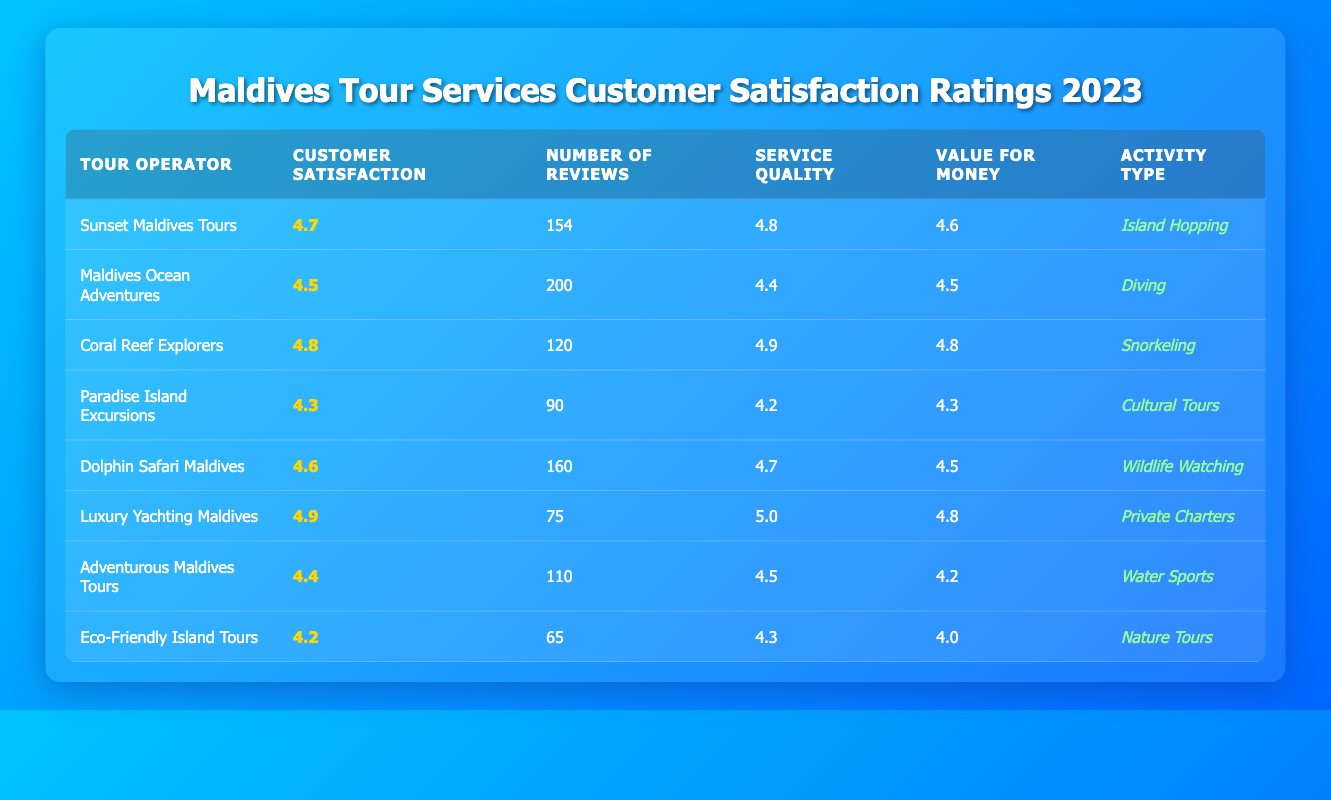What is the highest customer satisfaction rating among the tour operators? By reviewing the customer satisfaction ratings listed in the table, the values are 4.7, 4.5, 4.8, 4.3, 4.6, 4.9, 4.4, and 4.2. The highest value among these is 4.9.
Answer: 4.9 Which tour operator has the most reviews? The table includes the number of reviews for each operator: 154, 200, 120, 90, 160, 75, 110, and 65. The largest number, 200, is associated with Maldives Ocean Adventures.
Answer: Maldives Ocean Adventures Is there a tour operator with a customer satisfaction rating above 4.5 that also offers Wildlife Watching? Dolphin Safari Maldives has a customer satisfaction rating of 4.6, which is above 4.5, and offers Wildlife Watching, as indicated in the Activity Type column.
Answer: Yes What is the average service quality rating for all the tour operators? The service quality ratings are 4.8, 4.4, 4.9, 4.2, 4.7, 5.0, 4.5, and 4.3. Adding these values gives 36.8, and there are 8 operators, so the average is 36.8 / 8 = 4.6.
Answer: 4.6 Which activity type has the lowest customer satisfaction rating? Looking at the customer satisfaction ratings, the values are 4.7, 4.5, 4.8, 4.3, 4.6, 4.9, 4.4, and 4.2. The lowest value is 4.2, corresponding to Eco-Friendly Island Tours, which is categorized under Nature Tours.
Answer: Nature Tours How many tour operators have a value for money rating of 4.5 or higher? The value for money ratings are 4.6, 4.5, 4.8, 4.3, 4.5, 4.8, 4.2, and 4.0. Counting those rated 4.5 or higher gives us 5 operators (Sunset Maldives Tours, Maldives Ocean Adventures, Coral Reef Explorers, Dolphin Safari Maldives, and Luxury Yachting Maldives).
Answer: 5 Which tour operator provides the best service quality? By comparing the service quality ratings: 4.8, 4.4, 4.9, 4.2, 4.7, 5.0, 4.5, and 4.3, the highest rating is 5.0, which belongs to Luxury Yachting Maldives.
Answer: Luxury Yachting Maldives What is the difference in customer satisfaction ratings between the highest and lowest rated operators? The highest rating is 4.9 (Luxury Yachting Maldives) and the lowest is 4.2 (Eco-Friendly Island Tours). The difference is 4.9 - 4.2 = 0.7.
Answer: 0.7 Which operator has the lowest value for money rating and what is that rating? The value for money ratings are 4.6, 4.5, 4.8, 4.3, 4.5, 4.8, 4.2, and 4.0. The lowest rating is 4.0 from Eco-Friendly Island Tours.
Answer: Eco-Friendly Island Tours, 4.0 How many tour operators specialize in water sports activities? The activity types include Island Hopping, Diving, Snorkeling, Cultural Tours, Wildlife Watching, Private Charters, Water Sports, and Nature Tours. Only Adventurous Maldives Tours specializes in Water Sports, therefore there is only 1 operator.
Answer: 1 Which tour operator has a customer satisfaction rating of exactly 4.4? By checking the customer satisfaction ratings: 4.7, 4.5, 4.8, 4.3, 4.6, 4.9, 4.4, and 4.2, the value 4.4 corresponds to Adventurous Maldives Tours.
Answer: Adventurous Maldives Tours 